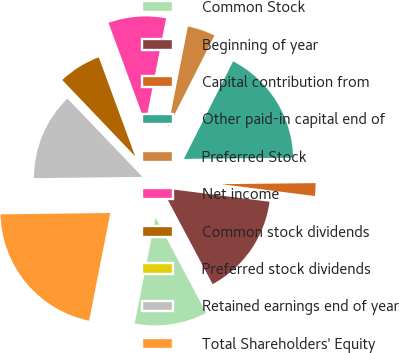<chart> <loc_0><loc_0><loc_500><loc_500><pie_chart><fcel>Common Stock<fcel>Beginning of year<fcel>Capital contribution from<fcel>Other paid-in capital end of<fcel>Preferred Stock<fcel>Net income<fcel>Common stock dividends<fcel>Preferred stock dividends<fcel>Retained earnings end of year<fcel>Total Shareholders' Equity<nl><fcel>10.87%<fcel>15.21%<fcel>2.19%<fcel>17.38%<fcel>4.36%<fcel>8.7%<fcel>6.53%<fcel>0.02%<fcel>13.04%<fcel>21.72%<nl></chart> 